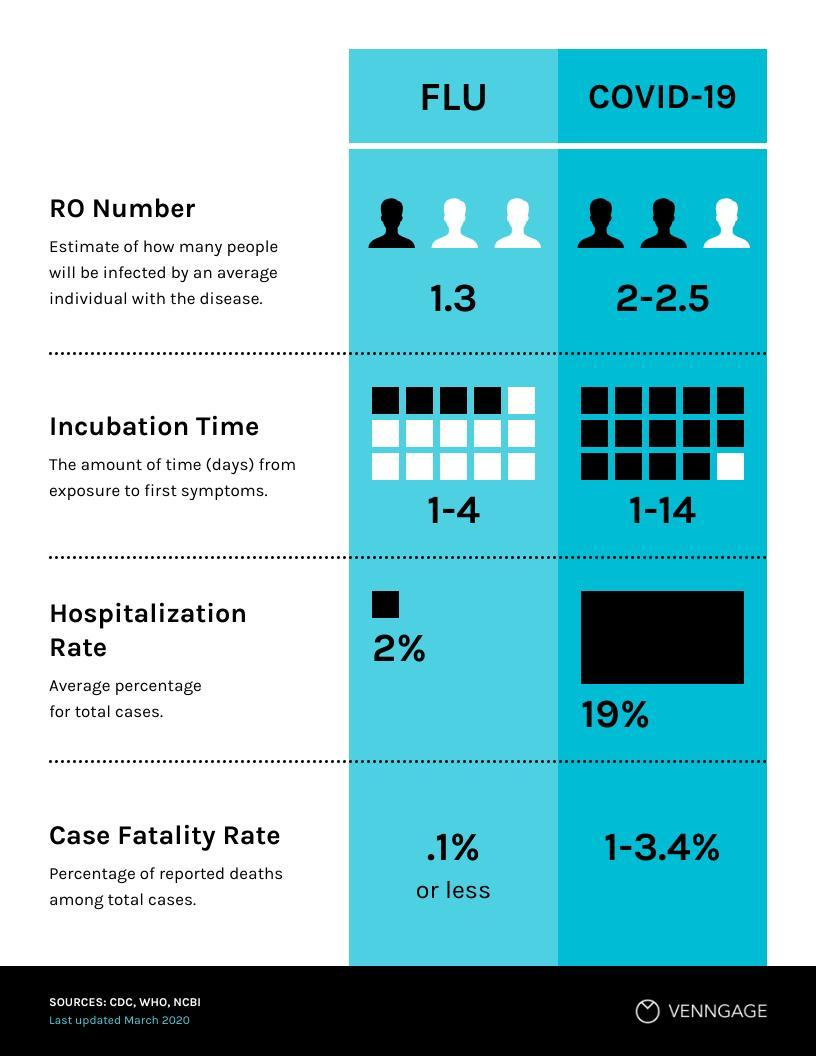By what percent is the hospitalisation rate of Covid-19 higher than flu?
Answer the question with a short phrase. 17% Which has higher RO number- flu or covid-19? COVID-19 Under Covid-19's incubation time, how many squares are black in colour? 14 